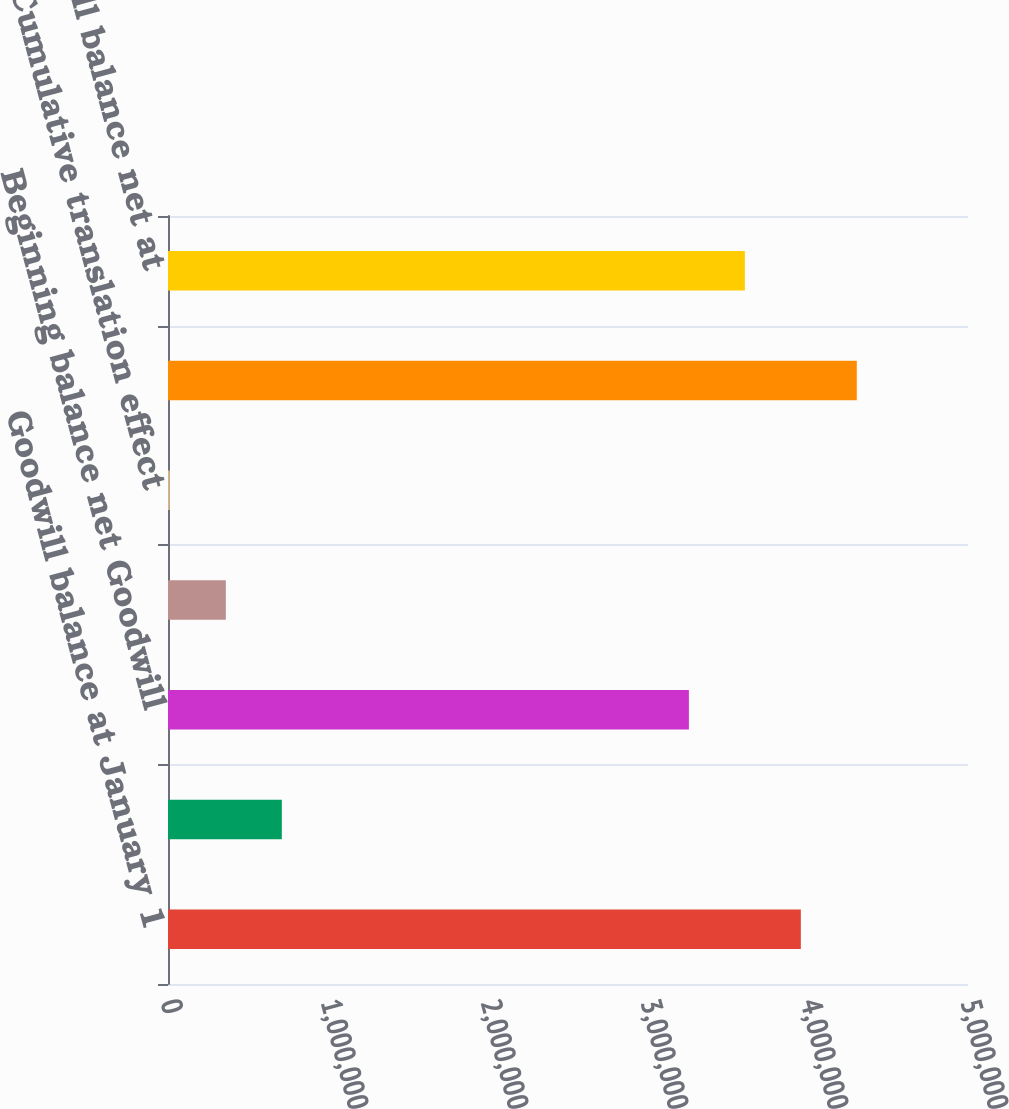<chart> <loc_0><loc_0><loc_500><loc_500><bar_chart><fcel>Goodwill balance at January 1<fcel>Accumulated impairment<fcel>Beginning balance net Goodwill<fcel>Goodwill aquired during year<fcel>Cumulative translation effect<fcel>Goodwill ending balance<fcel>Goodwill balance net at<nl><fcel>3.9552e+06<fcel>711389<fcel>3.25557e+06<fcel>361571<fcel>11752<fcel>4.30502e+06<fcel>3.60538e+06<nl></chart> 